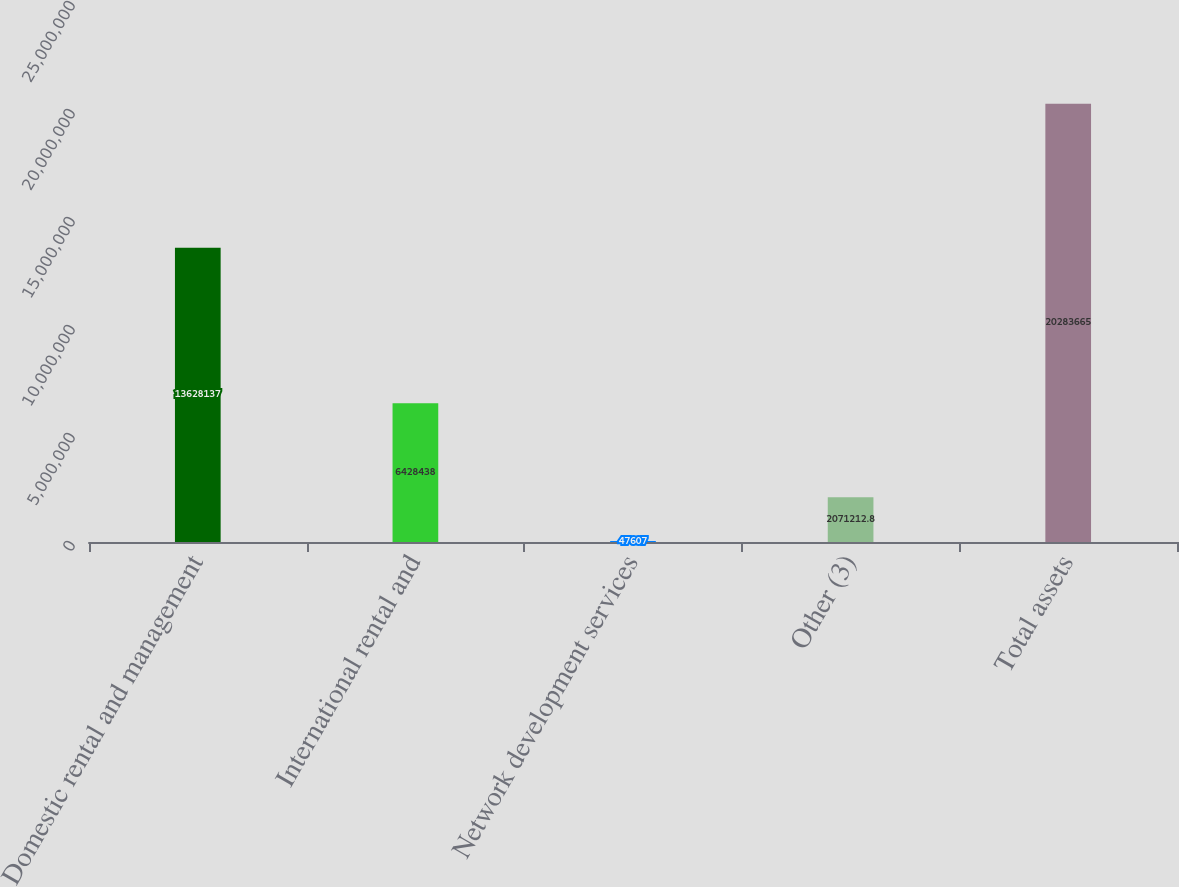Convert chart to OTSL. <chart><loc_0><loc_0><loc_500><loc_500><bar_chart><fcel>Domestic rental and management<fcel>International rental and<fcel>Network development services<fcel>Other (3)<fcel>Total assets<nl><fcel>1.36281e+07<fcel>6.42844e+06<fcel>47607<fcel>2.07121e+06<fcel>2.02837e+07<nl></chart> 